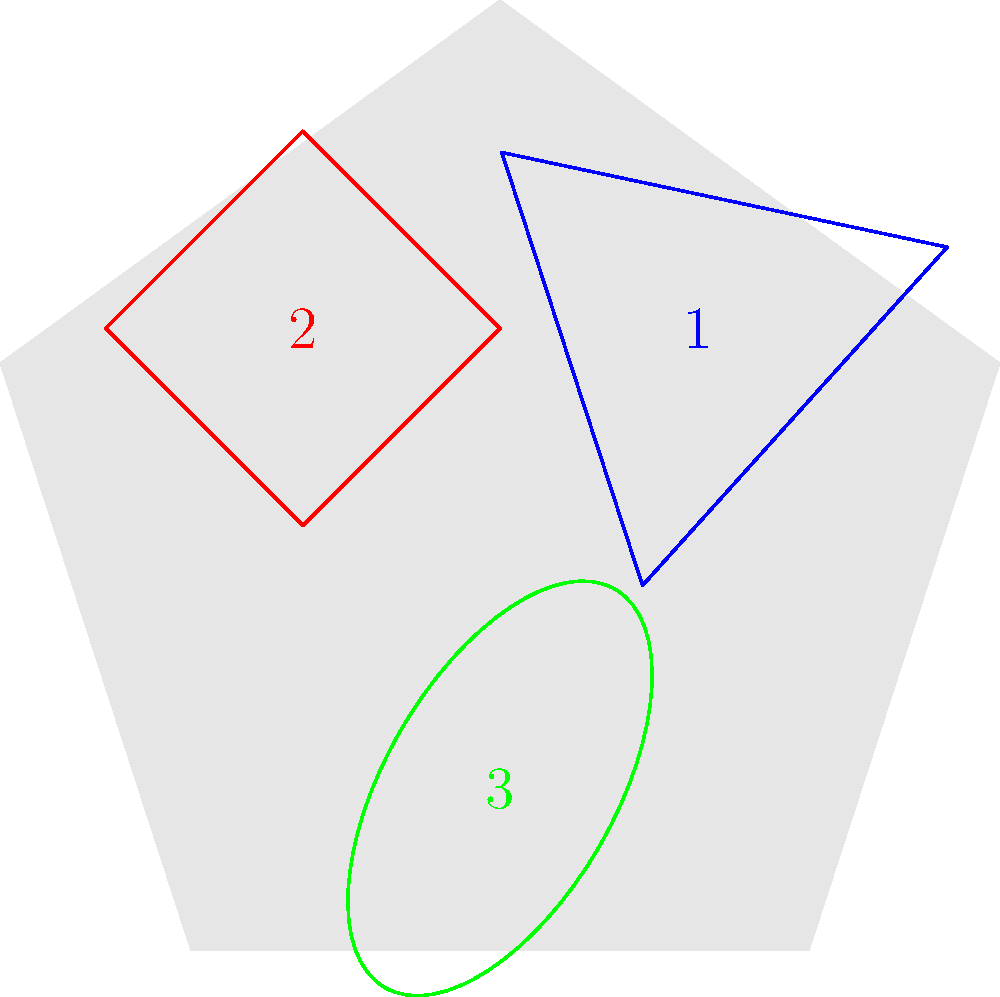Imagine you're assembling a tribute to Little Richard's iconic hairstyle. The image shows three parts of his hairstyle that need to be rotated and placed correctly. If part 1 (blue) needs to be rotated 60° clockwise, part 2 (red) needs to be rotated 90° counterclockwise, and part 3 (green) needs to be rotated 45° clockwise, what will be the final rotation of part 2 relative to its current position? Let's approach this step-by-step:

1. First, we need to understand that we're only concerned with the final position of part 2 (red).

2. The question states that part 2 needs to be rotated 90° counterclockwise from its current position.

3. In mathematical terms, a counterclockwise rotation is considered positive, while a clockwise rotation is negative.

4. Therefore, a 90° counterclockwise rotation can be expressed as +90°.

5. The current position of part 2 in the image is already rotated -45° (45° clockwise) from its original position.

6. To find the final rotation relative to the current position, we need to add the required rotation to the current rotation:

   Current rotation: -45°
   Required rotation: +90°
   
   Final rotation = Current rotation + Required rotation
                  = -45° + 90°
                  = 45°

7. Thus, the final rotation of part 2 relative to its current position will be 45° counterclockwise.
Answer: 45° counterclockwise 